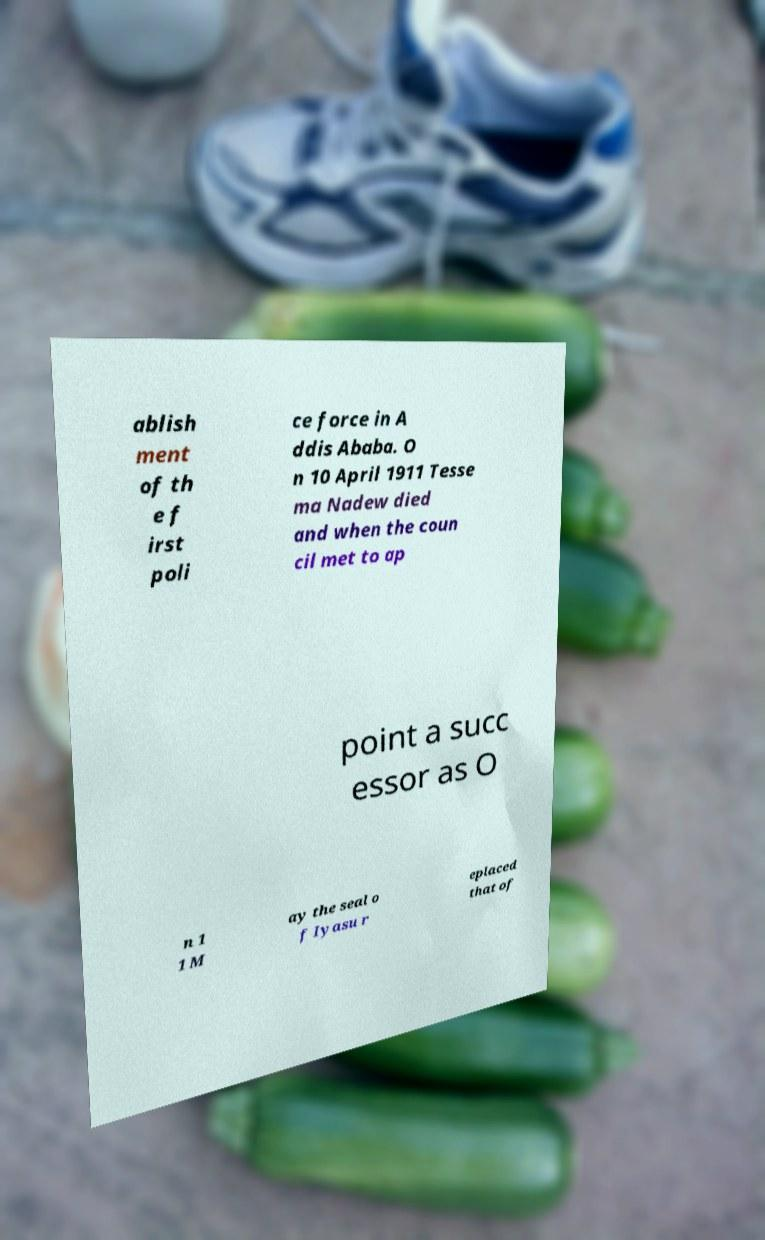Please identify and transcribe the text found in this image. ablish ment of th e f irst poli ce force in A ddis Ababa. O n 10 April 1911 Tesse ma Nadew died and when the coun cil met to ap point a succ essor as O n 1 1 M ay the seal o f Iyasu r eplaced that of 